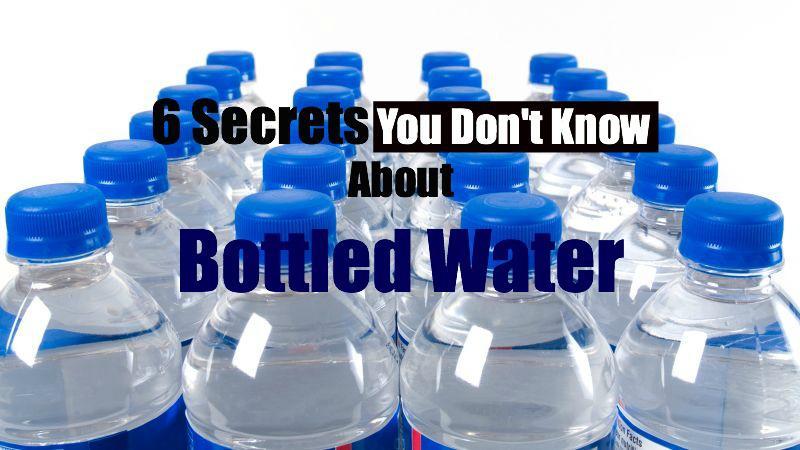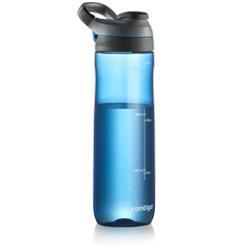The first image is the image on the left, the second image is the image on the right. Analyze the images presented: Is the assertion "A clear blue water bottle has a black top with loop." valid? Answer yes or no. Yes. The first image is the image on the left, the second image is the image on the right. Considering the images on both sides, is "An image shows one sport-type water bottle with a loop on the lid." valid? Answer yes or no. Yes. 